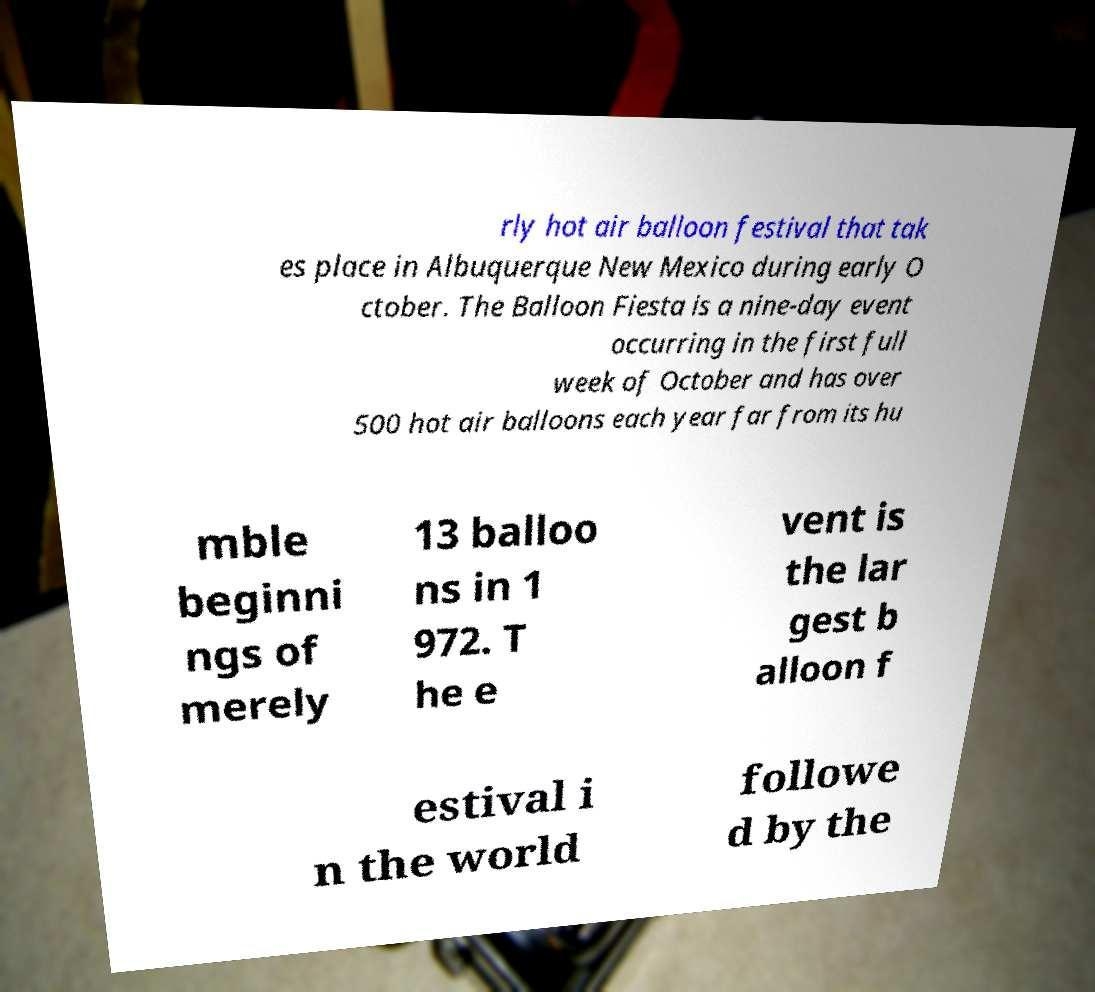For documentation purposes, I need the text within this image transcribed. Could you provide that? rly hot air balloon festival that tak es place in Albuquerque New Mexico during early O ctober. The Balloon Fiesta is a nine-day event occurring in the first full week of October and has over 500 hot air balloons each year far from its hu mble beginni ngs of merely 13 balloo ns in 1 972. T he e vent is the lar gest b alloon f estival i n the world followe d by the 